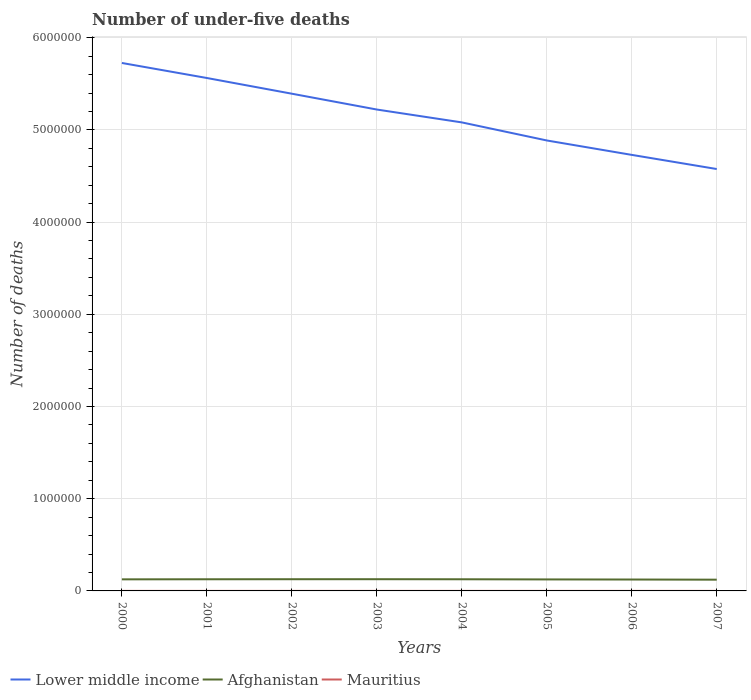Across all years, what is the maximum number of under-five deaths in Lower middle income?
Your answer should be compact. 4.58e+06. What is the total number of under-five deaths in Mauritius in the graph?
Provide a short and direct response. 34. What is the difference between the highest and the second highest number of under-five deaths in Lower middle income?
Keep it short and to the point. 1.15e+06. What is the difference between the highest and the lowest number of under-five deaths in Lower middle income?
Make the answer very short. 4. How many lines are there?
Your response must be concise. 3. What is the difference between two consecutive major ticks on the Y-axis?
Give a very brief answer. 1.00e+06. Are the values on the major ticks of Y-axis written in scientific E-notation?
Your answer should be very brief. No. Does the graph contain any zero values?
Provide a short and direct response. No. Where does the legend appear in the graph?
Your answer should be compact. Bottom left. What is the title of the graph?
Your answer should be very brief. Number of under-five deaths. Does "Finland" appear as one of the legend labels in the graph?
Keep it short and to the point. No. What is the label or title of the Y-axis?
Provide a succinct answer. Number of deaths. What is the Number of deaths in Lower middle income in 2000?
Your answer should be compact. 5.73e+06. What is the Number of deaths in Afghanistan in 2000?
Your response must be concise. 1.26e+05. What is the Number of deaths in Mauritius in 2000?
Offer a terse response. 322. What is the Number of deaths of Lower middle income in 2001?
Make the answer very short. 5.56e+06. What is the Number of deaths of Afghanistan in 2001?
Give a very brief answer. 1.26e+05. What is the Number of deaths of Mauritius in 2001?
Provide a succinct answer. 294. What is the Number of deaths of Lower middle income in 2002?
Ensure brevity in your answer.  5.39e+06. What is the Number of deaths in Afghanistan in 2002?
Provide a short and direct response. 1.27e+05. What is the Number of deaths in Mauritius in 2002?
Provide a short and direct response. 288. What is the Number of deaths in Lower middle income in 2003?
Provide a succinct answer. 5.22e+06. What is the Number of deaths of Afghanistan in 2003?
Provide a short and direct response. 1.27e+05. What is the Number of deaths in Mauritius in 2003?
Your response must be concise. 297. What is the Number of deaths in Lower middle income in 2004?
Offer a terse response. 5.08e+06. What is the Number of deaths in Afghanistan in 2004?
Keep it short and to the point. 1.26e+05. What is the Number of deaths of Mauritius in 2004?
Ensure brevity in your answer.  311. What is the Number of deaths in Lower middle income in 2005?
Keep it short and to the point. 4.89e+06. What is the Number of deaths in Afghanistan in 2005?
Give a very brief answer. 1.25e+05. What is the Number of deaths of Mauritius in 2005?
Provide a succinct answer. 317. What is the Number of deaths of Lower middle income in 2006?
Your answer should be very brief. 4.73e+06. What is the Number of deaths in Afghanistan in 2006?
Give a very brief answer. 1.24e+05. What is the Number of deaths in Mauritius in 2006?
Your answer should be very brief. 313. What is the Number of deaths in Lower middle income in 2007?
Provide a short and direct response. 4.58e+06. What is the Number of deaths in Afghanistan in 2007?
Provide a succinct answer. 1.22e+05. What is the Number of deaths in Mauritius in 2007?
Offer a terse response. 296. Across all years, what is the maximum Number of deaths in Lower middle income?
Keep it short and to the point. 5.73e+06. Across all years, what is the maximum Number of deaths of Afghanistan?
Keep it short and to the point. 1.27e+05. Across all years, what is the maximum Number of deaths in Mauritius?
Offer a very short reply. 322. Across all years, what is the minimum Number of deaths of Lower middle income?
Keep it short and to the point. 4.58e+06. Across all years, what is the minimum Number of deaths of Afghanistan?
Offer a terse response. 1.22e+05. Across all years, what is the minimum Number of deaths in Mauritius?
Your answer should be very brief. 288. What is the total Number of deaths in Lower middle income in the graph?
Provide a succinct answer. 4.12e+07. What is the total Number of deaths in Afghanistan in the graph?
Give a very brief answer. 1.00e+06. What is the total Number of deaths in Mauritius in the graph?
Keep it short and to the point. 2438. What is the difference between the Number of deaths in Lower middle income in 2000 and that in 2001?
Provide a short and direct response. 1.63e+05. What is the difference between the Number of deaths in Afghanistan in 2000 and that in 2001?
Provide a short and direct response. -740. What is the difference between the Number of deaths in Lower middle income in 2000 and that in 2002?
Offer a very short reply. 3.33e+05. What is the difference between the Number of deaths in Afghanistan in 2000 and that in 2002?
Your answer should be compact. -1273. What is the difference between the Number of deaths in Lower middle income in 2000 and that in 2003?
Offer a terse response. 5.05e+05. What is the difference between the Number of deaths of Afghanistan in 2000 and that in 2003?
Offer a terse response. -1524. What is the difference between the Number of deaths in Lower middle income in 2000 and that in 2004?
Keep it short and to the point. 6.44e+05. What is the difference between the Number of deaths in Afghanistan in 2000 and that in 2004?
Provide a short and direct response. -881. What is the difference between the Number of deaths of Lower middle income in 2000 and that in 2005?
Provide a short and direct response. 8.40e+05. What is the difference between the Number of deaths of Afghanistan in 2000 and that in 2005?
Your answer should be very brief. 818. What is the difference between the Number of deaths of Mauritius in 2000 and that in 2005?
Keep it short and to the point. 5. What is the difference between the Number of deaths in Lower middle income in 2000 and that in 2006?
Offer a terse response. 9.97e+05. What is the difference between the Number of deaths of Afghanistan in 2000 and that in 2006?
Ensure brevity in your answer.  1896. What is the difference between the Number of deaths in Mauritius in 2000 and that in 2006?
Provide a short and direct response. 9. What is the difference between the Number of deaths of Lower middle income in 2000 and that in 2007?
Keep it short and to the point. 1.15e+06. What is the difference between the Number of deaths of Afghanistan in 2000 and that in 2007?
Offer a very short reply. 3643. What is the difference between the Number of deaths of Mauritius in 2000 and that in 2007?
Provide a succinct answer. 26. What is the difference between the Number of deaths in Lower middle income in 2001 and that in 2002?
Make the answer very short. 1.70e+05. What is the difference between the Number of deaths of Afghanistan in 2001 and that in 2002?
Offer a terse response. -533. What is the difference between the Number of deaths of Mauritius in 2001 and that in 2002?
Make the answer very short. 6. What is the difference between the Number of deaths of Lower middle income in 2001 and that in 2003?
Ensure brevity in your answer.  3.42e+05. What is the difference between the Number of deaths of Afghanistan in 2001 and that in 2003?
Offer a terse response. -784. What is the difference between the Number of deaths in Lower middle income in 2001 and that in 2004?
Your response must be concise. 4.81e+05. What is the difference between the Number of deaths of Afghanistan in 2001 and that in 2004?
Your response must be concise. -141. What is the difference between the Number of deaths of Lower middle income in 2001 and that in 2005?
Provide a succinct answer. 6.77e+05. What is the difference between the Number of deaths of Afghanistan in 2001 and that in 2005?
Ensure brevity in your answer.  1558. What is the difference between the Number of deaths in Lower middle income in 2001 and that in 2006?
Your answer should be compact. 8.34e+05. What is the difference between the Number of deaths in Afghanistan in 2001 and that in 2006?
Make the answer very short. 2636. What is the difference between the Number of deaths in Mauritius in 2001 and that in 2006?
Your answer should be very brief. -19. What is the difference between the Number of deaths of Lower middle income in 2001 and that in 2007?
Make the answer very short. 9.87e+05. What is the difference between the Number of deaths of Afghanistan in 2001 and that in 2007?
Provide a succinct answer. 4383. What is the difference between the Number of deaths in Lower middle income in 2002 and that in 2003?
Make the answer very short. 1.72e+05. What is the difference between the Number of deaths of Afghanistan in 2002 and that in 2003?
Provide a short and direct response. -251. What is the difference between the Number of deaths in Lower middle income in 2002 and that in 2004?
Your answer should be very brief. 3.11e+05. What is the difference between the Number of deaths of Afghanistan in 2002 and that in 2004?
Your answer should be compact. 392. What is the difference between the Number of deaths in Mauritius in 2002 and that in 2004?
Provide a succinct answer. -23. What is the difference between the Number of deaths in Lower middle income in 2002 and that in 2005?
Give a very brief answer. 5.07e+05. What is the difference between the Number of deaths of Afghanistan in 2002 and that in 2005?
Offer a very short reply. 2091. What is the difference between the Number of deaths in Lower middle income in 2002 and that in 2006?
Provide a short and direct response. 6.64e+05. What is the difference between the Number of deaths in Afghanistan in 2002 and that in 2006?
Your response must be concise. 3169. What is the difference between the Number of deaths in Lower middle income in 2002 and that in 2007?
Offer a terse response. 8.17e+05. What is the difference between the Number of deaths of Afghanistan in 2002 and that in 2007?
Keep it short and to the point. 4916. What is the difference between the Number of deaths in Lower middle income in 2003 and that in 2004?
Provide a succinct answer. 1.39e+05. What is the difference between the Number of deaths of Afghanistan in 2003 and that in 2004?
Give a very brief answer. 643. What is the difference between the Number of deaths in Lower middle income in 2003 and that in 2005?
Your answer should be compact. 3.35e+05. What is the difference between the Number of deaths of Afghanistan in 2003 and that in 2005?
Provide a succinct answer. 2342. What is the difference between the Number of deaths in Lower middle income in 2003 and that in 2006?
Provide a short and direct response. 4.92e+05. What is the difference between the Number of deaths in Afghanistan in 2003 and that in 2006?
Ensure brevity in your answer.  3420. What is the difference between the Number of deaths of Lower middle income in 2003 and that in 2007?
Provide a succinct answer. 6.45e+05. What is the difference between the Number of deaths of Afghanistan in 2003 and that in 2007?
Keep it short and to the point. 5167. What is the difference between the Number of deaths of Mauritius in 2003 and that in 2007?
Make the answer very short. 1. What is the difference between the Number of deaths in Lower middle income in 2004 and that in 2005?
Keep it short and to the point. 1.96e+05. What is the difference between the Number of deaths in Afghanistan in 2004 and that in 2005?
Make the answer very short. 1699. What is the difference between the Number of deaths in Lower middle income in 2004 and that in 2006?
Offer a very short reply. 3.52e+05. What is the difference between the Number of deaths of Afghanistan in 2004 and that in 2006?
Make the answer very short. 2777. What is the difference between the Number of deaths of Mauritius in 2004 and that in 2006?
Offer a terse response. -2. What is the difference between the Number of deaths of Lower middle income in 2004 and that in 2007?
Make the answer very short. 5.06e+05. What is the difference between the Number of deaths of Afghanistan in 2004 and that in 2007?
Your response must be concise. 4524. What is the difference between the Number of deaths in Mauritius in 2004 and that in 2007?
Offer a terse response. 15. What is the difference between the Number of deaths of Lower middle income in 2005 and that in 2006?
Give a very brief answer. 1.56e+05. What is the difference between the Number of deaths of Afghanistan in 2005 and that in 2006?
Offer a very short reply. 1078. What is the difference between the Number of deaths in Lower middle income in 2005 and that in 2007?
Your answer should be compact. 3.10e+05. What is the difference between the Number of deaths in Afghanistan in 2005 and that in 2007?
Give a very brief answer. 2825. What is the difference between the Number of deaths of Lower middle income in 2006 and that in 2007?
Provide a succinct answer. 1.53e+05. What is the difference between the Number of deaths of Afghanistan in 2006 and that in 2007?
Provide a short and direct response. 1747. What is the difference between the Number of deaths in Lower middle income in 2000 and the Number of deaths in Afghanistan in 2001?
Provide a short and direct response. 5.60e+06. What is the difference between the Number of deaths of Lower middle income in 2000 and the Number of deaths of Mauritius in 2001?
Give a very brief answer. 5.73e+06. What is the difference between the Number of deaths of Afghanistan in 2000 and the Number of deaths of Mauritius in 2001?
Your response must be concise. 1.25e+05. What is the difference between the Number of deaths of Lower middle income in 2000 and the Number of deaths of Afghanistan in 2002?
Give a very brief answer. 5.60e+06. What is the difference between the Number of deaths of Lower middle income in 2000 and the Number of deaths of Mauritius in 2002?
Keep it short and to the point. 5.73e+06. What is the difference between the Number of deaths of Afghanistan in 2000 and the Number of deaths of Mauritius in 2002?
Provide a succinct answer. 1.25e+05. What is the difference between the Number of deaths in Lower middle income in 2000 and the Number of deaths in Afghanistan in 2003?
Your response must be concise. 5.60e+06. What is the difference between the Number of deaths of Lower middle income in 2000 and the Number of deaths of Mauritius in 2003?
Your answer should be very brief. 5.73e+06. What is the difference between the Number of deaths in Afghanistan in 2000 and the Number of deaths in Mauritius in 2003?
Give a very brief answer. 1.25e+05. What is the difference between the Number of deaths in Lower middle income in 2000 and the Number of deaths in Afghanistan in 2004?
Your answer should be compact. 5.60e+06. What is the difference between the Number of deaths of Lower middle income in 2000 and the Number of deaths of Mauritius in 2004?
Your response must be concise. 5.73e+06. What is the difference between the Number of deaths in Afghanistan in 2000 and the Number of deaths in Mauritius in 2004?
Offer a very short reply. 1.25e+05. What is the difference between the Number of deaths of Lower middle income in 2000 and the Number of deaths of Afghanistan in 2005?
Offer a terse response. 5.60e+06. What is the difference between the Number of deaths in Lower middle income in 2000 and the Number of deaths in Mauritius in 2005?
Offer a very short reply. 5.73e+06. What is the difference between the Number of deaths of Afghanistan in 2000 and the Number of deaths of Mauritius in 2005?
Provide a short and direct response. 1.25e+05. What is the difference between the Number of deaths of Lower middle income in 2000 and the Number of deaths of Afghanistan in 2006?
Offer a very short reply. 5.60e+06. What is the difference between the Number of deaths of Lower middle income in 2000 and the Number of deaths of Mauritius in 2006?
Provide a short and direct response. 5.73e+06. What is the difference between the Number of deaths in Afghanistan in 2000 and the Number of deaths in Mauritius in 2006?
Keep it short and to the point. 1.25e+05. What is the difference between the Number of deaths in Lower middle income in 2000 and the Number of deaths in Afghanistan in 2007?
Your answer should be very brief. 5.60e+06. What is the difference between the Number of deaths of Lower middle income in 2000 and the Number of deaths of Mauritius in 2007?
Make the answer very short. 5.73e+06. What is the difference between the Number of deaths in Afghanistan in 2000 and the Number of deaths in Mauritius in 2007?
Offer a terse response. 1.25e+05. What is the difference between the Number of deaths of Lower middle income in 2001 and the Number of deaths of Afghanistan in 2002?
Give a very brief answer. 5.44e+06. What is the difference between the Number of deaths of Lower middle income in 2001 and the Number of deaths of Mauritius in 2002?
Offer a very short reply. 5.56e+06. What is the difference between the Number of deaths in Afghanistan in 2001 and the Number of deaths in Mauritius in 2002?
Your answer should be very brief. 1.26e+05. What is the difference between the Number of deaths in Lower middle income in 2001 and the Number of deaths in Afghanistan in 2003?
Provide a succinct answer. 5.44e+06. What is the difference between the Number of deaths of Lower middle income in 2001 and the Number of deaths of Mauritius in 2003?
Ensure brevity in your answer.  5.56e+06. What is the difference between the Number of deaths in Afghanistan in 2001 and the Number of deaths in Mauritius in 2003?
Make the answer very short. 1.26e+05. What is the difference between the Number of deaths of Lower middle income in 2001 and the Number of deaths of Afghanistan in 2004?
Your answer should be compact. 5.44e+06. What is the difference between the Number of deaths of Lower middle income in 2001 and the Number of deaths of Mauritius in 2004?
Provide a succinct answer. 5.56e+06. What is the difference between the Number of deaths of Afghanistan in 2001 and the Number of deaths of Mauritius in 2004?
Provide a short and direct response. 1.26e+05. What is the difference between the Number of deaths of Lower middle income in 2001 and the Number of deaths of Afghanistan in 2005?
Offer a very short reply. 5.44e+06. What is the difference between the Number of deaths in Lower middle income in 2001 and the Number of deaths in Mauritius in 2005?
Provide a succinct answer. 5.56e+06. What is the difference between the Number of deaths in Afghanistan in 2001 and the Number of deaths in Mauritius in 2005?
Make the answer very short. 1.26e+05. What is the difference between the Number of deaths of Lower middle income in 2001 and the Number of deaths of Afghanistan in 2006?
Your answer should be very brief. 5.44e+06. What is the difference between the Number of deaths in Lower middle income in 2001 and the Number of deaths in Mauritius in 2006?
Give a very brief answer. 5.56e+06. What is the difference between the Number of deaths in Afghanistan in 2001 and the Number of deaths in Mauritius in 2006?
Make the answer very short. 1.26e+05. What is the difference between the Number of deaths of Lower middle income in 2001 and the Number of deaths of Afghanistan in 2007?
Give a very brief answer. 5.44e+06. What is the difference between the Number of deaths of Lower middle income in 2001 and the Number of deaths of Mauritius in 2007?
Keep it short and to the point. 5.56e+06. What is the difference between the Number of deaths of Afghanistan in 2001 and the Number of deaths of Mauritius in 2007?
Your response must be concise. 1.26e+05. What is the difference between the Number of deaths in Lower middle income in 2002 and the Number of deaths in Afghanistan in 2003?
Keep it short and to the point. 5.27e+06. What is the difference between the Number of deaths of Lower middle income in 2002 and the Number of deaths of Mauritius in 2003?
Your answer should be very brief. 5.39e+06. What is the difference between the Number of deaths in Afghanistan in 2002 and the Number of deaths in Mauritius in 2003?
Your answer should be very brief. 1.27e+05. What is the difference between the Number of deaths in Lower middle income in 2002 and the Number of deaths in Afghanistan in 2004?
Your answer should be compact. 5.27e+06. What is the difference between the Number of deaths of Lower middle income in 2002 and the Number of deaths of Mauritius in 2004?
Offer a very short reply. 5.39e+06. What is the difference between the Number of deaths of Afghanistan in 2002 and the Number of deaths of Mauritius in 2004?
Your answer should be very brief. 1.27e+05. What is the difference between the Number of deaths in Lower middle income in 2002 and the Number of deaths in Afghanistan in 2005?
Make the answer very short. 5.27e+06. What is the difference between the Number of deaths in Lower middle income in 2002 and the Number of deaths in Mauritius in 2005?
Provide a succinct answer. 5.39e+06. What is the difference between the Number of deaths of Afghanistan in 2002 and the Number of deaths of Mauritius in 2005?
Your answer should be very brief. 1.27e+05. What is the difference between the Number of deaths in Lower middle income in 2002 and the Number of deaths in Afghanistan in 2006?
Your answer should be compact. 5.27e+06. What is the difference between the Number of deaths in Lower middle income in 2002 and the Number of deaths in Mauritius in 2006?
Ensure brevity in your answer.  5.39e+06. What is the difference between the Number of deaths of Afghanistan in 2002 and the Number of deaths of Mauritius in 2006?
Your answer should be compact. 1.27e+05. What is the difference between the Number of deaths in Lower middle income in 2002 and the Number of deaths in Afghanistan in 2007?
Your response must be concise. 5.27e+06. What is the difference between the Number of deaths of Lower middle income in 2002 and the Number of deaths of Mauritius in 2007?
Make the answer very short. 5.39e+06. What is the difference between the Number of deaths of Afghanistan in 2002 and the Number of deaths of Mauritius in 2007?
Provide a succinct answer. 1.27e+05. What is the difference between the Number of deaths in Lower middle income in 2003 and the Number of deaths in Afghanistan in 2004?
Offer a very short reply. 5.09e+06. What is the difference between the Number of deaths in Lower middle income in 2003 and the Number of deaths in Mauritius in 2004?
Offer a very short reply. 5.22e+06. What is the difference between the Number of deaths in Afghanistan in 2003 and the Number of deaths in Mauritius in 2004?
Ensure brevity in your answer.  1.27e+05. What is the difference between the Number of deaths in Lower middle income in 2003 and the Number of deaths in Afghanistan in 2005?
Your answer should be compact. 5.10e+06. What is the difference between the Number of deaths in Lower middle income in 2003 and the Number of deaths in Mauritius in 2005?
Provide a short and direct response. 5.22e+06. What is the difference between the Number of deaths of Afghanistan in 2003 and the Number of deaths of Mauritius in 2005?
Offer a very short reply. 1.27e+05. What is the difference between the Number of deaths in Lower middle income in 2003 and the Number of deaths in Afghanistan in 2006?
Ensure brevity in your answer.  5.10e+06. What is the difference between the Number of deaths in Lower middle income in 2003 and the Number of deaths in Mauritius in 2006?
Your response must be concise. 5.22e+06. What is the difference between the Number of deaths in Afghanistan in 2003 and the Number of deaths in Mauritius in 2006?
Your answer should be compact. 1.27e+05. What is the difference between the Number of deaths in Lower middle income in 2003 and the Number of deaths in Afghanistan in 2007?
Ensure brevity in your answer.  5.10e+06. What is the difference between the Number of deaths of Lower middle income in 2003 and the Number of deaths of Mauritius in 2007?
Your answer should be compact. 5.22e+06. What is the difference between the Number of deaths of Afghanistan in 2003 and the Number of deaths of Mauritius in 2007?
Offer a very short reply. 1.27e+05. What is the difference between the Number of deaths of Lower middle income in 2004 and the Number of deaths of Afghanistan in 2005?
Give a very brief answer. 4.96e+06. What is the difference between the Number of deaths of Lower middle income in 2004 and the Number of deaths of Mauritius in 2005?
Offer a very short reply. 5.08e+06. What is the difference between the Number of deaths in Afghanistan in 2004 and the Number of deaths in Mauritius in 2005?
Provide a short and direct response. 1.26e+05. What is the difference between the Number of deaths of Lower middle income in 2004 and the Number of deaths of Afghanistan in 2006?
Provide a succinct answer. 4.96e+06. What is the difference between the Number of deaths in Lower middle income in 2004 and the Number of deaths in Mauritius in 2006?
Keep it short and to the point. 5.08e+06. What is the difference between the Number of deaths of Afghanistan in 2004 and the Number of deaths of Mauritius in 2006?
Offer a very short reply. 1.26e+05. What is the difference between the Number of deaths of Lower middle income in 2004 and the Number of deaths of Afghanistan in 2007?
Make the answer very short. 4.96e+06. What is the difference between the Number of deaths of Lower middle income in 2004 and the Number of deaths of Mauritius in 2007?
Your answer should be compact. 5.08e+06. What is the difference between the Number of deaths of Afghanistan in 2004 and the Number of deaths of Mauritius in 2007?
Your answer should be compact. 1.26e+05. What is the difference between the Number of deaths in Lower middle income in 2005 and the Number of deaths in Afghanistan in 2006?
Your answer should be compact. 4.76e+06. What is the difference between the Number of deaths in Lower middle income in 2005 and the Number of deaths in Mauritius in 2006?
Ensure brevity in your answer.  4.89e+06. What is the difference between the Number of deaths in Afghanistan in 2005 and the Number of deaths in Mauritius in 2006?
Your answer should be compact. 1.24e+05. What is the difference between the Number of deaths in Lower middle income in 2005 and the Number of deaths in Afghanistan in 2007?
Your answer should be compact. 4.76e+06. What is the difference between the Number of deaths of Lower middle income in 2005 and the Number of deaths of Mauritius in 2007?
Make the answer very short. 4.89e+06. What is the difference between the Number of deaths in Afghanistan in 2005 and the Number of deaths in Mauritius in 2007?
Provide a succinct answer. 1.25e+05. What is the difference between the Number of deaths in Lower middle income in 2006 and the Number of deaths in Afghanistan in 2007?
Make the answer very short. 4.61e+06. What is the difference between the Number of deaths in Lower middle income in 2006 and the Number of deaths in Mauritius in 2007?
Make the answer very short. 4.73e+06. What is the difference between the Number of deaths of Afghanistan in 2006 and the Number of deaths of Mauritius in 2007?
Your answer should be very brief. 1.23e+05. What is the average Number of deaths in Lower middle income per year?
Your answer should be very brief. 5.15e+06. What is the average Number of deaths of Afghanistan per year?
Ensure brevity in your answer.  1.25e+05. What is the average Number of deaths in Mauritius per year?
Make the answer very short. 304.75. In the year 2000, what is the difference between the Number of deaths in Lower middle income and Number of deaths in Afghanistan?
Offer a terse response. 5.60e+06. In the year 2000, what is the difference between the Number of deaths of Lower middle income and Number of deaths of Mauritius?
Provide a short and direct response. 5.73e+06. In the year 2000, what is the difference between the Number of deaths of Afghanistan and Number of deaths of Mauritius?
Your answer should be very brief. 1.25e+05. In the year 2001, what is the difference between the Number of deaths of Lower middle income and Number of deaths of Afghanistan?
Make the answer very short. 5.44e+06. In the year 2001, what is the difference between the Number of deaths of Lower middle income and Number of deaths of Mauritius?
Keep it short and to the point. 5.56e+06. In the year 2001, what is the difference between the Number of deaths in Afghanistan and Number of deaths in Mauritius?
Your answer should be compact. 1.26e+05. In the year 2002, what is the difference between the Number of deaths in Lower middle income and Number of deaths in Afghanistan?
Your response must be concise. 5.27e+06. In the year 2002, what is the difference between the Number of deaths in Lower middle income and Number of deaths in Mauritius?
Offer a terse response. 5.39e+06. In the year 2002, what is the difference between the Number of deaths in Afghanistan and Number of deaths in Mauritius?
Give a very brief answer. 1.27e+05. In the year 2003, what is the difference between the Number of deaths of Lower middle income and Number of deaths of Afghanistan?
Provide a succinct answer. 5.09e+06. In the year 2003, what is the difference between the Number of deaths in Lower middle income and Number of deaths in Mauritius?
Your answer should be very brief. 5.22e+06. In the year 2003, what is the difference between the Number of deaths in Afghanistan and Number of deaths in Mauritius?
Provide a short and direct response. 1.27e+05. In the year 2004, what is the difference between the Number of deaths in Lower middle income and Number of deaths in Afghanistan?
Your response must be concise. 4.95e+06. In the year 2004, what is the difference between the Number of deaths of Lower middle income and Number of deaths of Mauritius?
Ensure brevity in your answer.  5.08e+06. In the year 2004, what is the difference between the Number of deaths of Afghanistan and Number of deaths of Mauritius?
Keep it short and to the point. 1.26e+05. In the year 2005, what is the difference between the Number of deaths of Lower middle income and Number of deaths of Afghanistan?
Offer a terse response. 4.76e+06. In the year 2005, what is the difference between the Number of deaths in Lower middle income and Number of deaths in Mauritius?
Provide a succinct answer. 4.89e+06. In the year 2005, what is the difference between the Number of deaths in Afghanistan and Number of deaths in Mauritius?
Your response must be concise. 1.24e+05. In the year 2006, what is the difference between the Number of deaths in Lower middle income and Number of deaths in Afghanistan?
Offer a very short reply. 4.61e+06. In the year 2006, what is the difference between the Number of deaths of Lower middle income and Number of deaths of Mauritius?
Offer a very short reply. 4.73e+06. In the year 2006, what is the difference between the Number of deaths in Afghanistan and Number of deaths in Mauritius?
Provide a succinct answer. 1.23e+05. In the year 2007, what is the difference between the Number of deaths in Lower middle income and Number of deaths in Afghanistan?
Give a very brief answer. 4.45e+06. In the year 2007, what is the difference between the Number of deaths of Lower middle income and Number of deaths of Mauritius?
Your answer should be very brief. 4.58e+06. In the year 2007, what is the difference between the Number of deaths of Afghanistan and Number of deaths of Mauritius?
Your response must be concise. 1.22e+05. What is the ratio of the Number of deaths of Lower middle income in 2000 to that in 2001?
Make the answer very short. 1.03. What is the ratio of the Number of deaths in Mauritius in 2000 to that in 2001?
Make the answer very short. 1.1. What is the ratio of the Number of deaths in Lower middle income in 2000 to that in 2002?
Make the answer very short. 1.06. What is the ratio of the Number of deaths in Afghanistan in 2000 to that in 2002?
Your answer should be very brief. 0.99. What is the ratio of the Number of deaths of Mauritius in 2000 to that in 2002?
Your answer should be compact. 1.12. What is the ratio of the Number of deaths of Lower middle income in 2000 to that in 2003?
Provide a short and direct response. 1.1. What is the ratio of the Number of deaths of Afghanistan in 2000 to that in 2003?
Make the answer very short. 0.99. What is the ratio of the Number of deaths in Mauritius in 2000 to that in 2003?
Provide a succinct answer. 1.08. What is the ratio of the Number of deaths of Lower middle income in 2000 to that in 2004?
Offer a terse response. 1.13. What is the ratio of the Number of deaths of Mauritius in 2000 to that in 2004?
Your response must be concise. 1.04. What is the ratio of the Number of deaths in Lower middle income in 2000 to that in 2005?
Provide a succinct answer. 1.17. What is the ratio of the Number of deaths of Afghanistan in 2000 to that in 2005?
Offer a very short reply. 1.01. What is the ratio of the Number of deaths in Mauritius in 2000 to that in 2005?
Your response must be concise. 1.02. What is the ratio of the Number of deaths of Lower middle income in 2000 to that in 2006?
Make the answer very short. 1.21. What is the ratio of the Number of deaths of Afghanistan in 2000 to that in 2006?
Keep it short and to the point. 1.02. What is the ratio of the Number of deaths of Mauritius in 2000 to that in 2006?
Offer a terse response. 1.03. What is the ratio of the Number of deaths of Lower middle income in 2000 to that in 2007?
Offer a very short reply. 1.25. What is the ratio of the Number of deaths of Afghanistan in 2000 to that in 2007?
Offer a terse response. 1.03. What is the ratio of the Number of deaths of Mauritius in 2000 to that in 2007?
Ensure brevity in your answer.  1.09. What is the ratio of the Number of deaths of Lower middle income in 2001 to that in 2002?
Provide a succinct answer. 1.03. What is the ratio of the Number of deaths of Mauritius in 2001 to that in 2002?
Provide a short and direct response. 1.02. What is the ratio of the Number of deaths in Lower middle income in 2001 to that in 2003?
Ensure brevity in your answer.  1.07. What is the ratio of the Number of deaths in Mauritius in 2001 to that in 2003?
Offer a very short reply. 0.99. What is the ratio of the Number of deaths in Lower middle income in 2001 to that in 2004?
Ensure brevity in your answer.  1.09. What is the ratio of the Number of deaths of Mauritius in 2001 to that in 2004?
Provide a succinct answer. 0.95. What is the ratio of the Number of deaths of Lower middle income in 2001 to that in 2005?
Give a very brief answer. 1.14. What is the ratio of the Number of deaths of Afghanistan in 2001 to that in 2005?
Give a very brief answer. 1.01. What is the ratio of the Number of deaths in Mauritius in 2001 to that in 2005?
Provide a short and direct response. 0.93. What is the ratio of the Number of deaths in Lower middle income in 2001 to that in 2006?
Make the answer very short. 1.18. What is the ratio of the Number of deaths in Afghanistan in 2001 to that in 2006?
Provide a succinct answer. 1.02. What is the ratio of the Number of deaths in Mauritius in 2001 to that in 2006?
Offer a very short reply. 0.94. What is the ratio of the Number of deaths of Lower middle income in 2001 to that in 2007?
Offer a terse response. 1.22. What is the ratio of the Number of deaths of Afghanistan in 2001 to that in 2007?
Make the answer very short. 1.04. What is the ratio of the Number of deaths of Mauritius in 2001 to that in 2007?
Offer a terse response. 0.99. What is the ratio of the Number of deaths in Lower middle income in 2002 to that in 2003?
Offer a terse response. 1.03. What is the ratio of the Number of deaths in Afghanistan in 2002 to that in 2003?
Make the answer very short. 1. What is the ratio of the Number of deaths in Mauritius in 2002 to that in 2003?
Your answer should be compact. 0.97. What is the ratio of the Number of deaths of Lower middle income in 2002 to that in 2004?
Offer a very short reply. 1.06. What is the ratio of the Number of deaths of Afghanistan in 2002 to that in 2004?
Your answer should be compact. 1. What is the ratio of the Number of deaths of Mauritius in 2002 to that in 2004?
Provide a short and direct response. 0.93. What is the ratio of the Number of deaths in Lower middle income in 2002 to that in 2005?
Offer a terse response. 1.1. What is the ratio of the Number of deaths of Afghanistan in 2002 to that in 2005?
Give a very brief answer. 1.02. What is the ratio of the Number of deaths in Mauritius in 2002 to that in 2005?
Ensure brevity in your answer.  0.91. What is the ratio of the Number of deaths in Lower middle income in 2002 to that in 2006?
Make the answer very short. 1.14. What is the ratio of the Number of deaths of Afghanistan in 2002 to that in 2006?
Offer a terse response. 1.03. What is the ratio of the Number of deaths of Mauritius in 2002 to that in 2006?
Provide a short and direct response. 0.92. What is the ratio of the Number of deaths in Lower middle income in 2002 to that in 2007?
Your answer should be compact. 1.18. What is the ratio of the Number of deaths in Afghanistan in 2002 to that in 2007?
Ensure brevity in your answer.  1.04. What is the ratio of the Number of deaths in Lower middle income in 2003 to that in 2004?
Offer a terse response. 1.03. What is the ratio of the Number of deaths in Afghanistan in 2003 to that in 2004?
Offer a very short reply. 1.01. What is the ratio of the Number of deaths of Mauritius in 2003 to that in 2004?
Provide a short and direct response. 0.95. What is the ratio of the Number of deaths of Lower middle income in 2003 to that in 2005?
Your answer should be compact. 1.07. What is the ratio of the Number of deaths of Afghanistan in 2003 to that in 2005?
Offer a very short reply. 1.02. What is the ratio of the Number of deaths in Mauritius in 2003 to that in 2005?
Provide a succinct answer. 0.94. What is the ratio of the Number of deaths in Lower middle income in 2003 to that in 2006?
Your response must be concise. 1.1. What is the ratio of the Number of deaths in Afghanistan in 2003 to that in 2006?
Your answer should be very brief. 1.03. What is the ratio of the Number of deaths of Mauritius in 2003 to that in 2006?
Your response must be concise. 0.95. What is the ratio of the Number of deaths of Lower middle income in 2003 to that in 2007?
Keep it short and to the point. 1.14. What is the ratio of the Number of deaths in Afghanistan in 2003 to that in 2007?
Offer a very short reply. 1.04. What is the ratio of the Number of deaths in Lower middle income in 2004 to that in 2005?
Give a very brief answer. 1.04. What is the ratio of the Number of deaths in Afghanistan in 2004 to that in 2005?
Provide a succinct answer. 1.01. What is the ratio of the Number of deaths in Mauritius in 2004 to that in 2005?
Your response must be concise. 0.98. What is the ratio of the Number of deaths of Lower middle income in 2004 to that in 2006?
Your answer should be very brief. 1.07. What is the ratio of the Number of deaths of Afghanistan in 2004 to that in 2006?
Your response must be concise. 1.02. What is the ratio of the Number of deaths in Mauritius in 2004 to that in 2006?
Offer a very short reply. 0.99. What is the ratio of the Number of deaths of Lower middle income in 2004 to that in 2007?
Provide a succinct answer. 1.11. What is the ratio of the Number of deaths in Afghanistan in 2004 to that in 2007?
Offer a very short reply. 1.04. What is the ratio of the Number of deaths of Mauritius in 2004 to that in 2007?
Make the answer very short. 1.05. What is the ratio of the Number of deaths of Lower middle income in 2005 to that in 2006?
Provide a succinct answer. 1.03. What is the ratio of the Number of deaths of Afghanistan in 2005 to that in 2006?
Provide a succinct answer. 1.01. What is the ratio of the Number of deaths of Mauritius in 2005 to that in 2006?
Keep it short and to the point. 1.01. What is the ratio of the Number of deaths of Lower middle income in 2005 to that in 2007?
Your response must be concise. 1.07. What is the ratio of the Number of deaths in Afghanistan in 2005 to that in 2007?
Ensure brevity in your answer.  1.02. What is the ratio of the Number of deaths of Mauritius in 2005 to that in 2007?
Ensure brevity in your answer.  1.07. What is the ratio of the Number of deaths in Lower middle income in 2006 to that in 2007?
Your answer should be compact. 1.03. What is the ratio of the Number of deaths in Afghanistan in 2006 to that in 2007?
Offer a very short reply. 1.01. What is the ratio of the Number of deaths of Mauritius in 2006 to that in 2007?
Offer a terse response. 1.06. What is the difference between the highest and the second highest Number of deaths of Lower middle income?
Provide a short and direct response. 1.63e+05. What is the difference between the highest and the second highest Number of deaths in Afghanistan?
Keep it short and to the point. 251. What is the difference between the highest and the lowest Number of deaths in Lower middle income?
Offer a very short reply. 1.15e+06. What is the difference between the highest and the lowest Number of deaths of Afghanistan?
Give a very brief answer. 5167. 